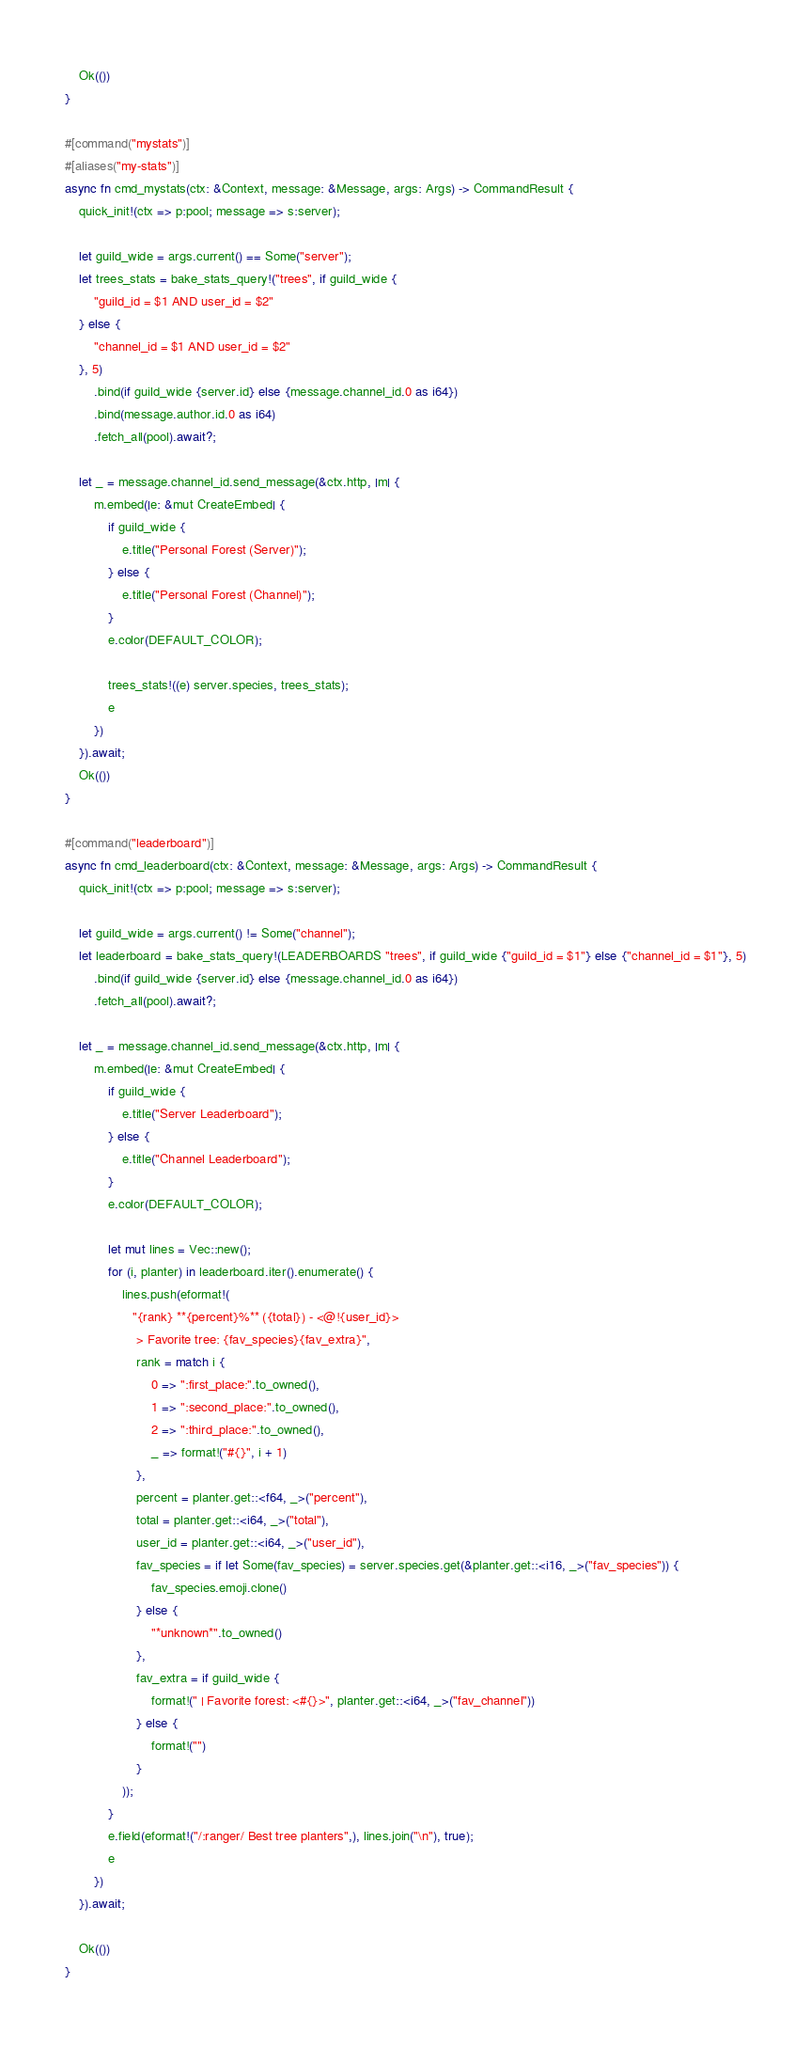<code> <loc_0><loc_0><loc_500><loc_500><_Rust_>    Ok(())
}

#[command("mystats")]
#[aliases("my-stats")]
async fn cmd_mystats(ctx: &Context, message: &Message, args: Args) -> CommandResult {
    quick_init!(ctx => p:pool; message => s:server);

    let guild_wide = args.current() == Some("server");
    let trees_stats = bake_stats_query!("trees", if guild_wide {
        "guild_id = $1 AND user_id = $2"
    } else {
        "channel_id = $1 AND user_id = $2"
    }, 5)
        .bind(if guild_wide {server.id} else {message.channel_id.0 as i64})
        .bind(message.author.id.0 as i64)
        .fetch_all(pool).await?;

    let _ = message.channel_id.send_message(&ctx.http, |m| {
        m.embed(|e: &mut CreateEmbed| {
            if guild_wide {
                e.title("Personal Forest (Server)");
            } else {
                e.title("Personal Forest (Channel)");
            }
            e.color(DEFAULT_COLOR);

            trees_stats!((e) server.species, trees_stats);
            e
        })
    }).await;
    Ok(())
}

#[command("leaderboard")]
async fn cmd_leaderboard(ctx: &Context, message: &Message, args: Args) -> CommandResult {
    quick_init!(ctx => p:pool; message => s:server);

    let guild_wide = args.current() != Some("channel");
    let leaderboard = bake_stats_query!(LEADERBOARDS "trees", if guild_wide {"guild_id = $1"} else {"channel_id = $1"}, 5)
        .bind(if guild_wide {server.id} else {message.channel_id.0 as i64})
        .fetch_all(pool).await?;

    let _ = message.channel_id.send_message(&ctx.http, |m| {
        m.embed(|e: &mut CreateEmbed| {
            if guild_wide {
                e.title("Server Leaderboard");
            } else {
                e.title("Channel Leaderboard");
            }
            e.color(DEFAULT_COLOR);

            let mut lines = Vec::new();
            for (i, planter) in leaderboard.iter().enumerate() {
                lines.push(eformat!(
                   "{rank} **{percent}%** ({total}) - <@!{user_id}>
                    > Favorite tree: {fav_species}{fav_extra}",
                    rank = match i {
                        0 => ":first_place:".to_owned(),
                        1 => ":second_place:".to_owned(),
                        2 => ":third_place:".to_owned(),
                        _ => format!("#{}", i + 1)
                    },
                    percent = planter.get::<f64, _>("percent"), 
                    total = planter.get::<i64, _>("total"),
                    user_id = planter.get::<i64, _>("user_id"),
                    fav_species = if let Some(fav_species) = server.species.get(&planter.get::<i16, _>("fav_species")) {
                        fav_species.emoji.clone()
                    } else {
                        "*unknown*".to_owned()
                    },
                    fav_extra = if guild_wide {
                        format!(" | Favorite forest: <#{}>", planter.get::<i64, _>("fav_channel"))
                    } else {
                        format!("")
                    }
                ));
            }
            e.field(eformat!("/:ranger/ Best tree planters",), lines.join("\n"), true);
            e
        })
    }).await;

    Ok(())
}
</code> 